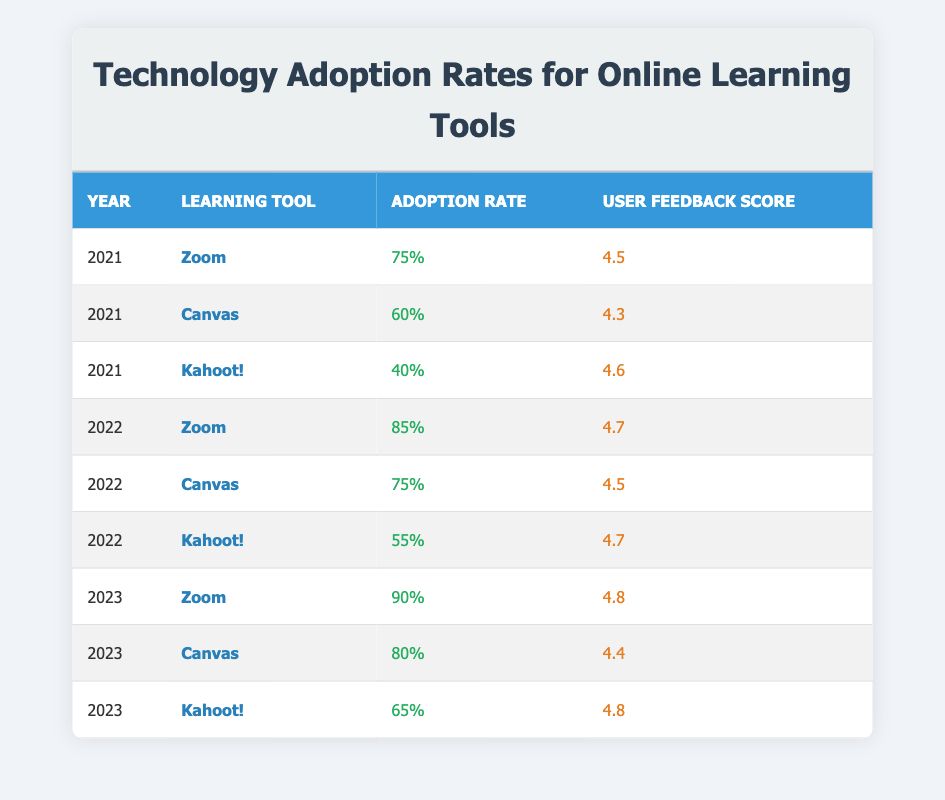What was the user feedback score for Zoom in 2022? In 2022, the user feedback score for Zoom is listed in the table as 4.7.
Answer: 4.7 What is the adoption rate for Canvas in 2023? The table shows that the adoption rate for Canvas in 2023 is 80%.
Answer: 80% Did the adoption rate for Kahoot! increase from 2021 to 2022? In 2021, Kahoot! had an adoption rate of 40%, and in 2022 it increased to 55%. Therefore, it did increase.
Answer: Yes What was the average user feedback score for all three learning tools in 2021? The user feedback scores were 4.5 for Zoom, 4.3 for Canvas, and 4.6 for Kahoot!. The total is 4.5 + 4.3 + 4.6 = 13.4, and dividing by 3 gives an average score of 13.4 / 3 = 4.47.
Answer: 4.47 Which learning tool had the highest adoption rate in 2023? The table shows that Zoom had the highest adoption rate in 2023 at 90%, compared to 80% for Canvas and 65% for Kahoot!.
Answer: Zoom Has the user feedback score for Canvas decreased by 2023 compared to 2021? The user feedback score for Canvas was 4.3 in 2021 and is 4.4 in 2023, indicating it has increased instead of decreased.
Answer: No What is the overall trend in the adoption rates for Zoom from 2021 to 2023? The adoption rate for Zoom was 75% in 2021, increased to 85% in 2022, and then reached 90% in 2023. Therefore, the trend shows a consistent increase each year.
Answer: Increasing What is the difference in adoption rates for Kahoot! between 2022 and 2023? In 2022, Kahoot! had an adoption rate of 55%, and in 2023 it was 65%. The difference is calculated as 65% - 55% = 10%.
Answer: 10% 